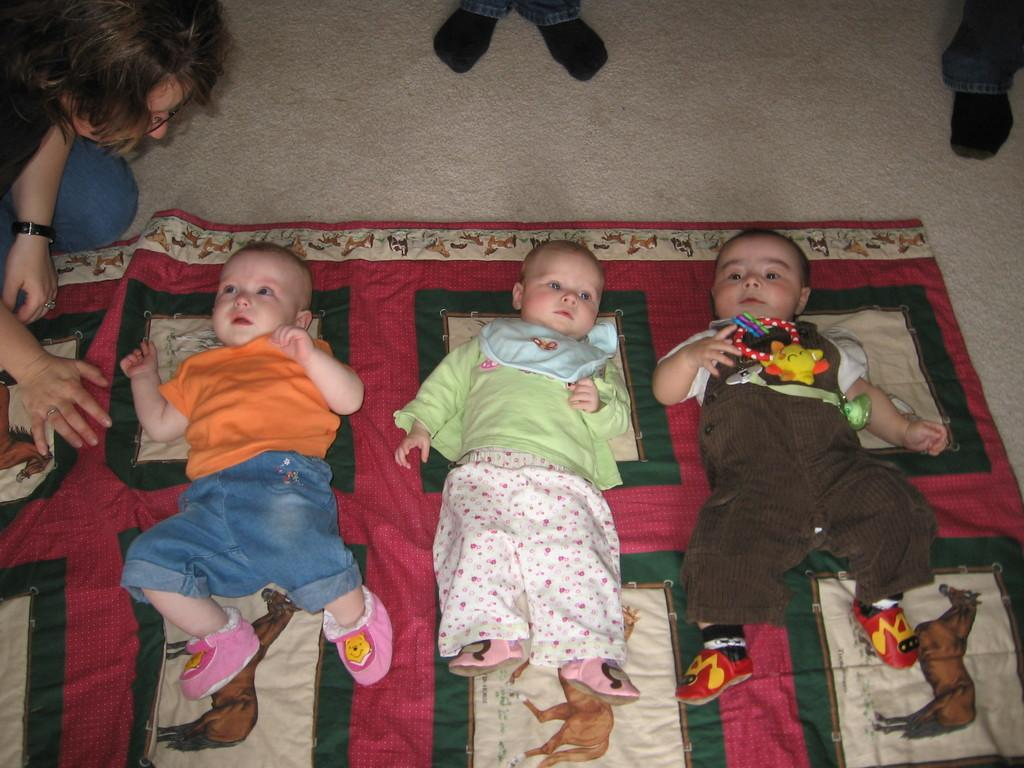What are the kids doing in the image? The kids are laying on a blanket in the image. Can you describe the person in the image? The person is wearing spectacles and a wrist watch in the image. Where is the person located in the image? The person is located at the left side of the image. What type of powder is being used by the kids in the image? There is no powder visible in the image; the kids are laying on a blanket. 